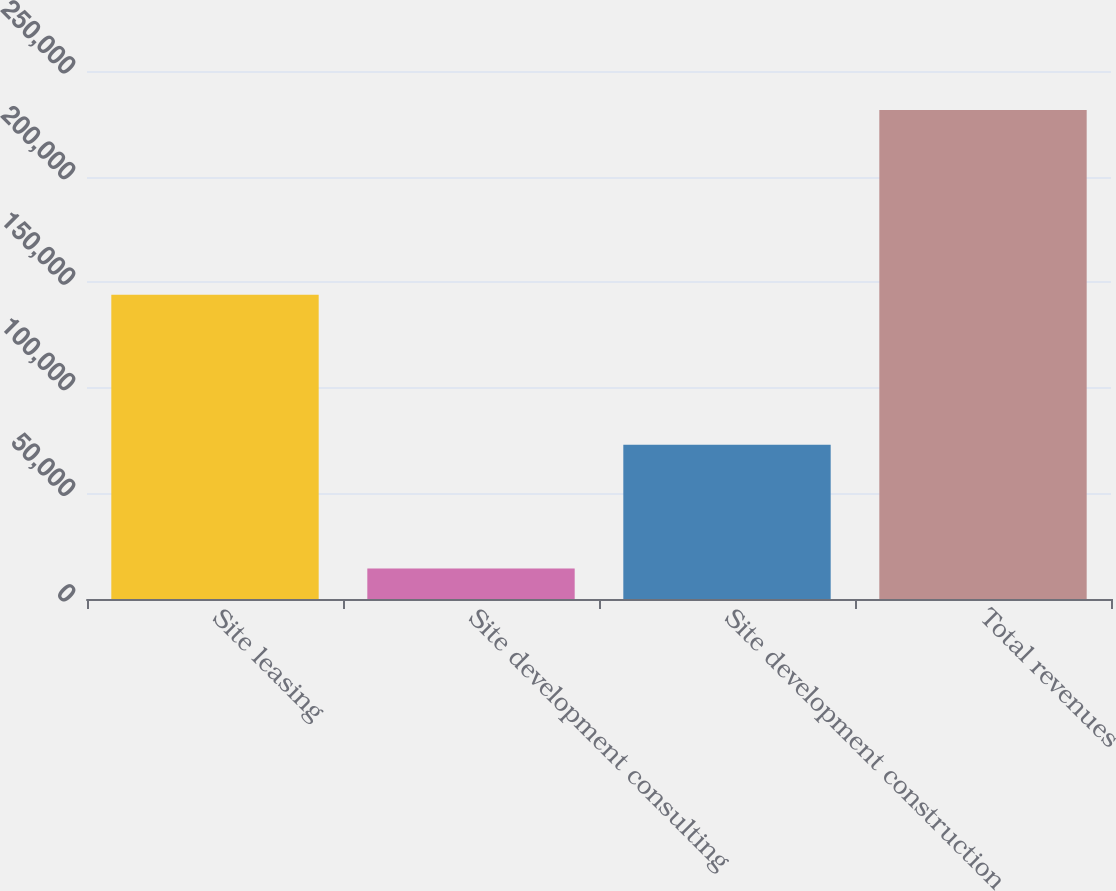<chart> <loc_0><loc_0><loc_500><loc_500><bar_chart><fcel>Site leasing<fcel>Site development consulting<fcel>Site development construction<fcel>Total revenues<nl><fcel>144004<fcel>14456<fcel>73022<fcel>231482<nl></chart> 